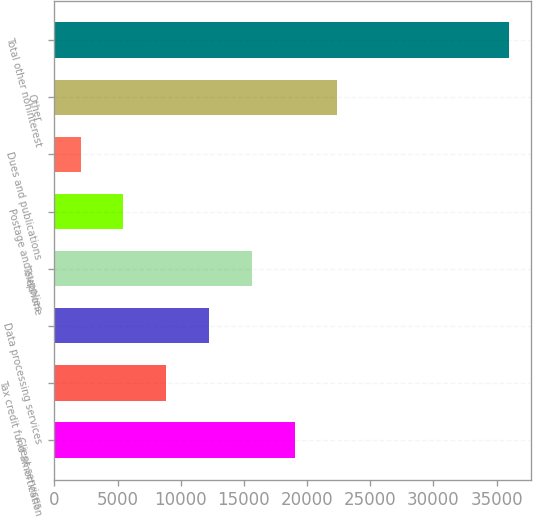Convert chart to OTSL. <chart><loc_0><loc_0><loc_500><loc_500><bar_chart><fcel>Client services<fcel>Tax credit fund amortization<fcel>Data processing services<fcel>Telephone<fcel>Postage and supplies<fcel>Dues and publications<fcel>Other<fcel>Total other noninterest<nl><fcel>19014.5<fcel>8846<fcel>12235.5<fcel>15625<fcel>5456.5<fcel>2067<fcel>22404<fcel>35962<nl></chart> 